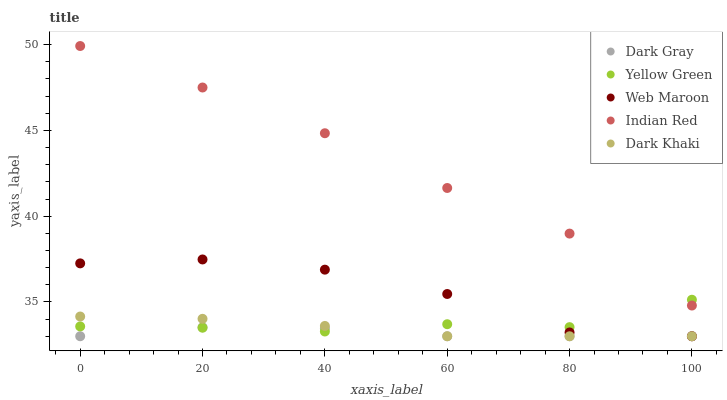Does Dark Gray have the minimum area under the curve?
Answer yes or no. Yes. Does Indian Red have the maximum area under the curve?
Answer yes or no. Yes. Does Dark Khaki have the minimum area under the curve?
Answer yes or no. No. Does Dark Khaki have the maximum area under the curve?
Answer yes or no. No. Is Dark Khaki the smoothest?
Answer yes or no. Yes. Is Web Maroon the roughest?
Answer yes or no. Yes. Is Web Maroon the smoothest?
Answer yes or no. No. Is Dark Khaki the roughest?
Answer yes or no. No. Does Dark Gray have the lowest value?
Answer yes or no. Yes. Does Yellow Green have the lowest value?
Answer yes or no. No. Does Indian Red have the highest value?
Answer yes or no. Yes. Does Dark Khaki have the highest value?
Answer yes or no. No. Is Web Maroon less than Indian Red?
Answer yes or no. Yes. Is Indian Red greater than Dark Gray?
Answer yes or no. Yes. Does Dark Khaki intersect Dark Gray?
Answer yes or no. Yes. Is Dark Khaki less than Dark Gray?
Answer yes or no. No. Is Dark Khaki greater than Dark Gray?
Answer yes or no. No. Does Web Maroon intersect Indian Red?
Answer yes or no. No. 